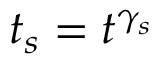<formula> <loc_0><loc_0><loc_500><loc_500>t _ { s } = t ^ { \gamma _ { s } }</formula> 